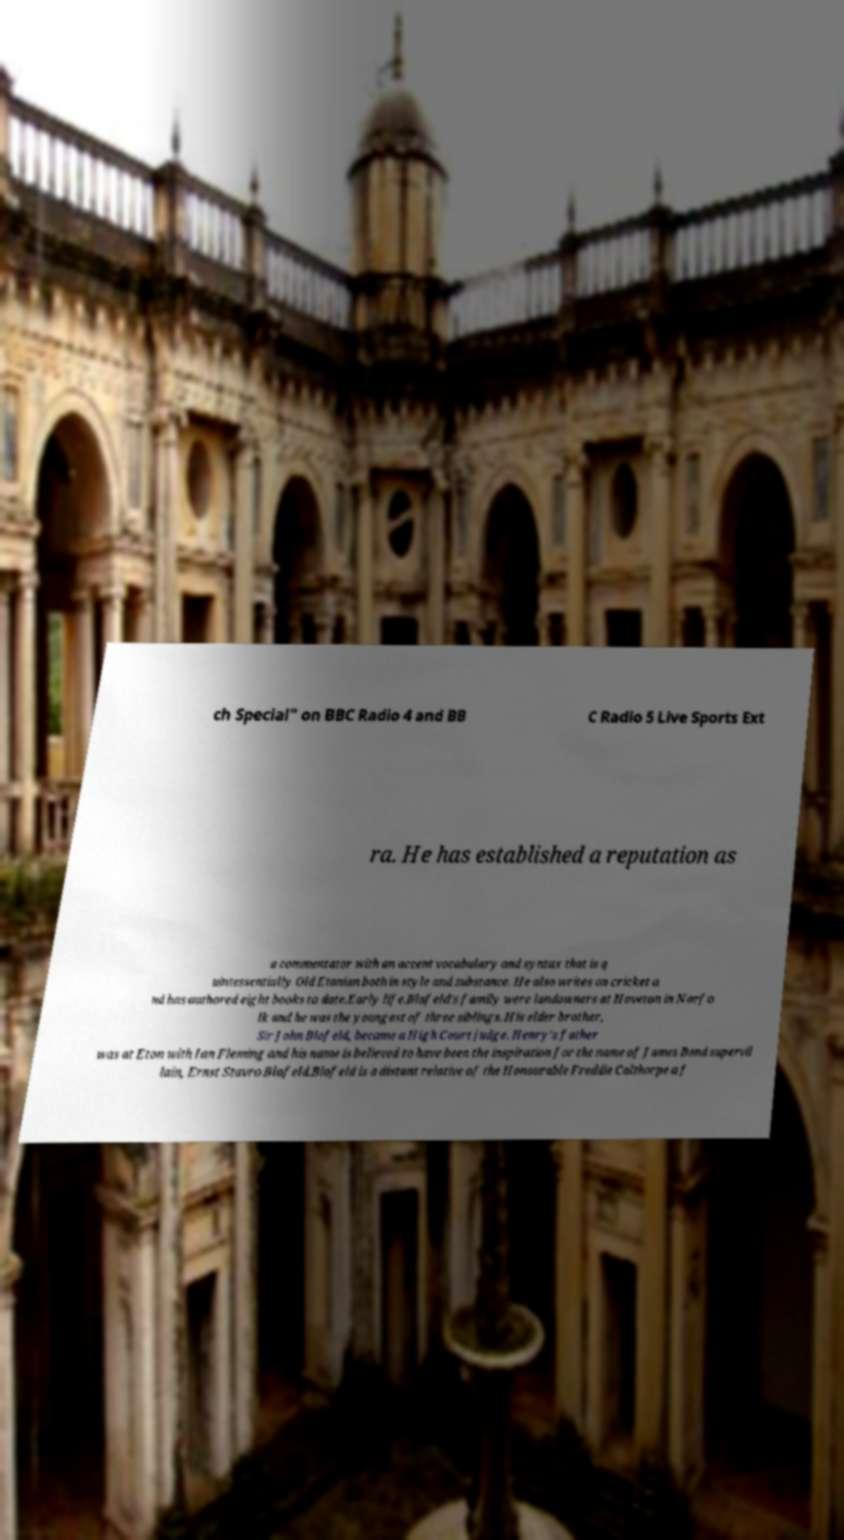For documentation purposes, I need the text within this image transcribed. Could you provide that? ch Special" on BBC Radio 4 and BB C Radio 5 Live Sports Ext ra. He has established a reputation as a commentator with an accent vocabulary and syntax that is q uintessentially Old Etonian both in style and substance. He also writes on cricket a nd has authored eight books to date.Early life.Blofeld's family were landowners at Hoveton in Norfo lk and he was the youngest of three siblings. His elder brother, Sir John Blofeld, became a High Court judge. Henry's father was at Eton with Ian Fleming and his name is believed to have been the inspiration for the name of James Bond supervil lain, Ernst Stavro Blofeld.Blofeld is a distant relative of the Honourable Freddie Calthorpe a f 